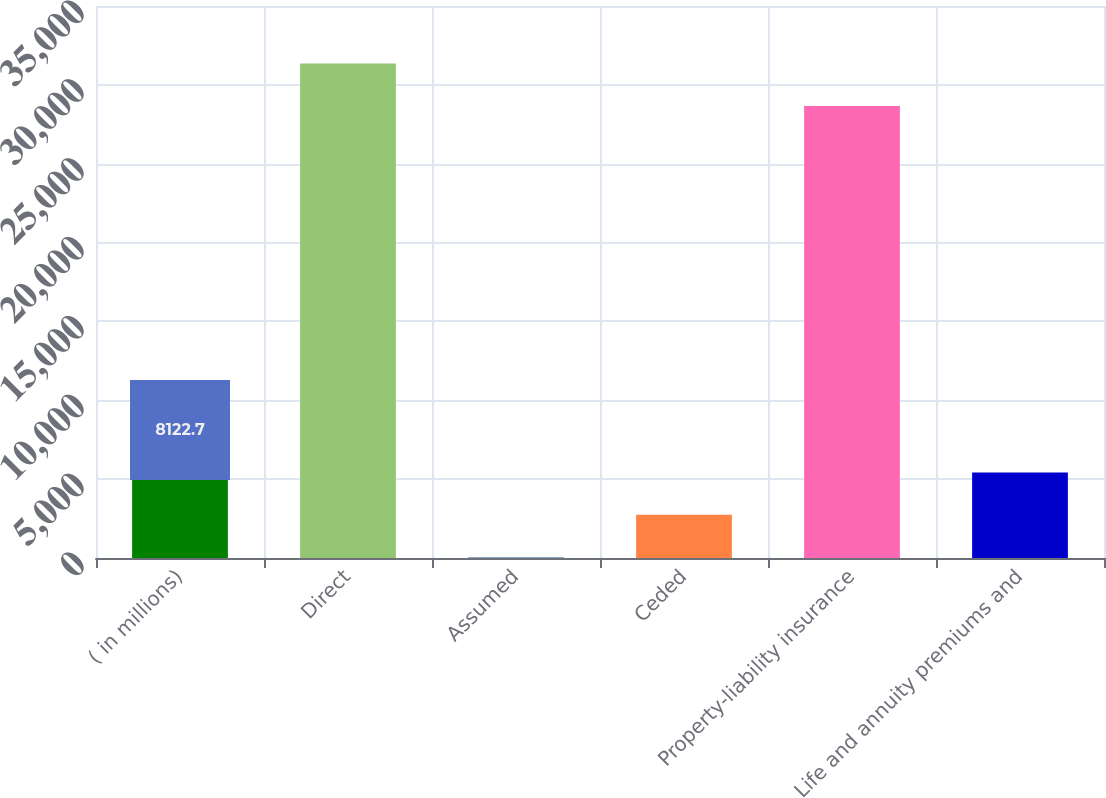<chart> <loc_0><loc_0><loc_500><loc_500><bar_chart><fcel>( in millions)<fcel>Direct<fcel>Assumed<fcel>Ceded<fcel>Property-liability insurance<fcel>Life and annuity premiums and<nl><fcel>8122.7<fcel>31358.8<fcel>41<fcel>2734.9<fcel>28664.9<fcel>5428.8<nl></chart> 